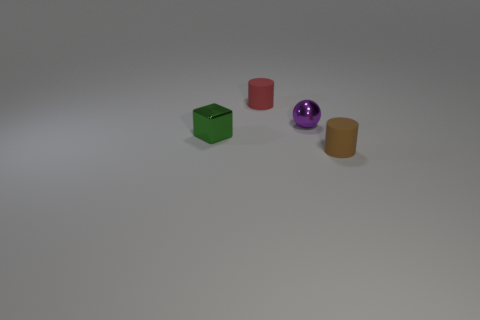There is a cylinder right of the red cylinder; what is its size?
Make the answer very short. Small. There is a cylinder that is in front of the rubber thing that is behind the brown rubber cylinder; what is its size?
Give a very brief answer. Small. There is a brown cylinder that is the same size as the red rubber cylinder; what material is it?
Ensure brevity in your answer.  Rubber. There is a purple shiny thing; are there any tiny rubber cylinders on the right side of it?
Make the answer very short. Yes. Are there an equal number of tiny cylinders that are behind the green cube and tiny blue metal objects?
Offer a very short reply. No. The other rubber thing that is the same size as the brown thing is what shape?
Give a very brief answer. Cylinder. What is the purple sphere made of?
Provide a short and direct response. Metal. There is a thing that is behind the green metal thing and on the right side of the red matte cylinder; what color is it?
Offer a very short reply. Purple. Are there the same number of green metal things that are right of the brown object and tiny brown matte things left of the small red matte thing?
Your answer should be compact. Yes. What is the color of the thing that is the same material as the tiny red cylinder?
Offer a terse response. Brown. 